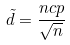Convert formula to latex. <formula><loc_0><loc_0><loc_500><loc_500>\tilde { d } = \frac { n c p } { \sqrt { n } }</formula> 